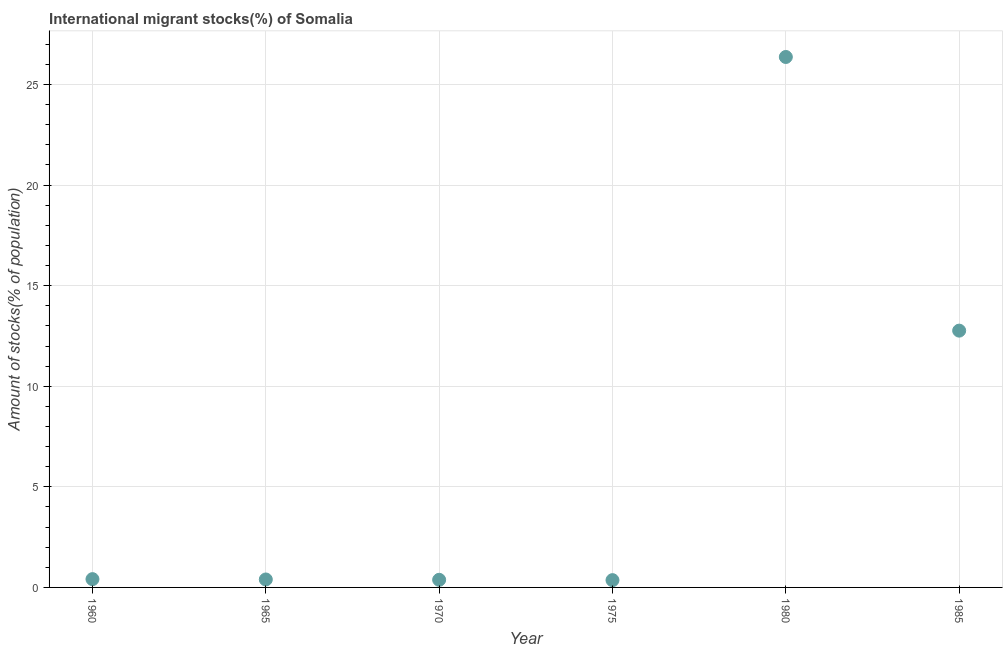What is the number of international migrant stocks in 1970?
Offer a terse response. 0.38. Across all years, what is the maximum number of international migrant stocks?
Make the answer very short. 26.37. Across all years, what is the minimum number of international migrant stocks?
Ensure brevity in your answer.  0.36. In which year was the number of international migrant stocks minimum?
Your answer should be very brief. 1975. What is the sum of the number of international migrant stocks?
Ensure brevity in your answer.  40.68. What is the difference between the number of international migrant stocks in 1965 and 1980?
Your response must be concise. -25.97. What is the average number of international migrant stocks per year?
Give a very brief answer. 6.78. What is the median number of international migrant stocks?
Your response must be concise. 0.4. Do a majority of the years between 1975 and 1960 (inclusive) have number of international migrant stocks greater than 10 %?
Keep it short and to the point. Yes. What is the ratio of the number of international migrant stocks in 1960 to that in 1970?
Provide a short and direct response. 1.09. Is the number of international migrant stocks in 1975 less than that in 1985?
Offer a very short reply. Yes. What is the difference between the highest and the second highest number of international migrant stocks?
Offer a terse response. 13.6. What is the difference between the highest and the lowest number of international migrant stocks?
Provide a short and direct response. 26. Does the number of international migrant stocks monotonically increase over the years?
Provide a succinct answer. No. What is the difference between two consecutive major ticks on the Y-axis?
Provide a short and direct response. 5. Are the values on the major ticks of Y-axis written in scientific E-notation?
Your answer should be very brief. No. Does the graph contain grids?
Keep it short and to the point. Yes. What is the title of the graph?
Provide a short and direct response. International migrant stocks(%) of Somalia. What is the label or title of the X-axis?
Ensure brevity in your answer.  Year. What is the label or title of the Y-axis?
Offer a very short reply. Amount of stocks(% of population). What is the Amount of stocks(% of population) in 1960?
Provide a short and direct response. 0.41. What is the Amount of stocks(% of population) in 1965?
Keep it short and to the point. 0.4. What is the Amount of stocks(% of population) in 1970?
Your response must be concise. 0.38. What is the Amount of stocks(% of population) in 1975?
Keep it short and to the point. 0.36. What is the Amount of stocks(% of population) in 1980?
Provide a succinct answer. 26.37. What is the Amount of stocks(% of population) in 1985?
Give a very brief answer. 12.76. What is the difference between the Amount of stocks(% of population) in 1960 and 1965?
Provide a succinct answer. 0.02. What is the difference between the Amount of stocks(% of population) in 1960 and 1970?
Provide a short and direct response. 0.03. What is the difference between the Amount of stocks(% of population) in 1960 and 1975?
Provide a succinct answer. 0.05. What is the difference between the Amount of stocks(% of population) in 1960 and 1980?
Keep it short and to the point. -25.95. What is the difference between the Amount of stocks(% of population) in 1960 and 1985?
Your answer should be compact. -12.35. What is the difference between the Amount of stocks(% of population) in 1965 and 1970?
Your answer should be compact. 0.02. What is the difference between the Amount of stocks(% of population) in 1965 and 1975?
Give a very brief answer. 0.03. What is the difference between the Amount of stocks(% of population) in 1965 and 1980?
Ensure brevity in your answer.  -25.97. What is the difference between the Amount of stocks(% of population) in 1965 and 1985?
Your answer should be compact. -12.37. What is the difference between the Amount of stocks(% of population) in 1970 and 1975?
Offer a very short reply. 0.02. What is the difference between the Amount of stocks(% of population) in 1970 and 1980?
Make the answer very short. -25.99. What is the difference between the Amount of stocks(% of population) in 1970 and 1985?
Give a very brief answer. -12.39. What is the difference between the Amount of stocks(% of population) in 1975 and 1980?
Provide a short and direct response. -26. What is the difference between the Amount of stocks(% of population) in 1975 and 1985?
Your answer should be very brief. -12.4. What is the difference between the Amount of stocks(% of population) in 1980 and 1985?
Give a very brief answer. 13.6. What is the ratio of the Amount of stocks(% of population) in 1960 to that in 1965?
Your answer should be very brief. 1.04. What is the ratio of the Amount of stocks(% of population) in 1960 to that in 1970?
Make the answer very short. 1.09. What is the ratio of the Amount of stocks(% of population) in 1960 to that in 1975?
Make the answer very short. 1.14. What is the ratio of the Amount of stocks(% of population) in 1960 to that in 1980?
Give a very brief answer. 0.02. What is the ratio of the Amount of stocks(% of population) in 1960 to that in 1985?
Offer a very short reply. 0.03. What is the ratio of the Amount of stocks(% of population) in 1965 to that in 1970?
Keep it short and to the point. 1.04. What is the ratio of the Amount of stocks(% of population) in 1965 to that in 1975?
Give a very brief answer. 1.09. What is the ratio of the Amount of stocks(% of population) in 1965 to that in 1980?
Your answer should be very brief. 0.01. What is the ratio of the Amount of stocks(% of population) in 1965 to that in 1985?
Provide a succinct answer. 0.03. What is the ratio of the Amount of stocks(% of population) in 1970 to that in 1975?
Offer a terse response. 1.05. What is the ratio of the Amount of stocks(% of population) in 1970 to that in 1980?
Ensure brevity in your answer.  0.01. What is the ratio of the Amount of stocks(% of population) in 1975 to that in 1980?
Keep it short and to the point. 0.01. What is the ratio of the Amount of stocks(% of population) in 1975 to that in 1985?
Keep it short and to the point. 0.03. What is the ratio of the Amount of stocks(% of population) in 1980 to that in 1985?
Make the answer very short. 2.07. 